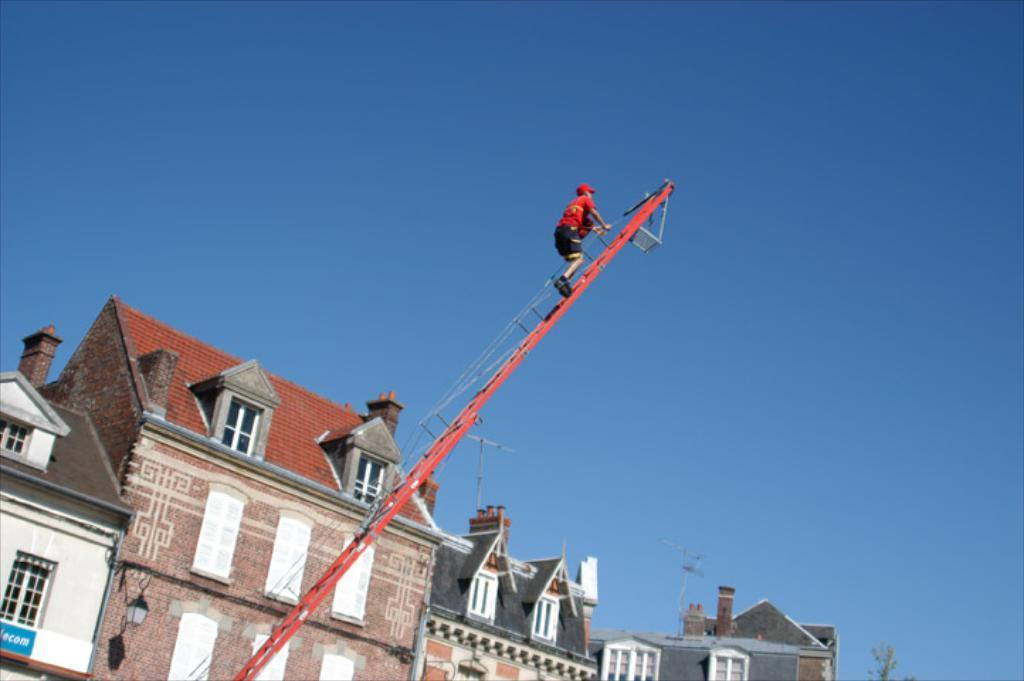What is the person in the image doing? The person is on a metal ladder in the image. What is the person holding while on the ladder? The person is holding ropes. What type of structures can be seen in the image? There are buildings with windows in the image. What type of lighting is present in the image? Street lamps are present in the image. What type of vegetation is in the image? There is a tree in the image. What is the condition of the sky in the image? The sky is visible and appears cloudy in the image. What is the weight of the notebook on the person's back in the image? There is no notebook present in the image, so it is not possible to determine its weight. 